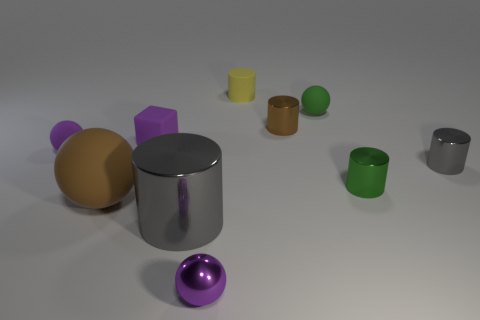Are there any tiny metal balls of the same color as the small cube?
Your answer should be very brief. Yes. The tiny metallic object that is the same color as the big rubber object is what shape?
Keep it short and to the point. Cylinder. How many tiny things are either green rubber spheres or yellow shiny things?
Offer a very short reply. 1. What color is the big thing that is the same shape as the tiny yellow matte object?
Offer a very short reply. Gray. Do the green cylinder and the green matte object have the same size?
Offer a terse response. Yes. What number of objects are tiny purple balls or brown things left of the small matte cylinder?
Your response must be concise. 3. The small matte thing behind the green ball to the right of the metallic sphere is what color?
Make the answer very short. Yellow. There is a matte ball that is in front of the small green cylinder; is it the same color as the tiny matte cylinder?
Offer a terse response. No. What material is the gray cylinder that is on the left side of the purple shiny sphere?
Provide a short and direct response. Metal. How big is the purple rubber block?
Give a very brief answer. Small. 